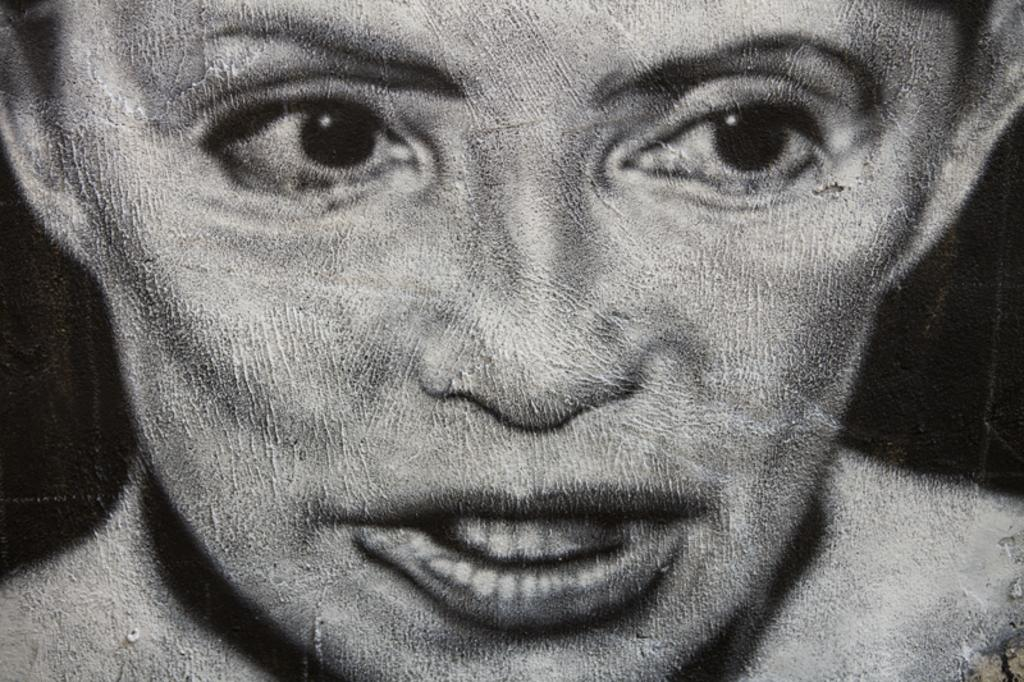What is the main subject of the image? There is a picture of a woman in the image. Can you describe the background of the image? The background of the image is dark. How many corn plants are growing in the garden in the image? There is no garden or corn plants present in the image; it features a picture of a woman with a dark background. What is the weight of the woman in the image? The weight of the woman cannot be determined from the image alone, as it only shows a picture of her. 